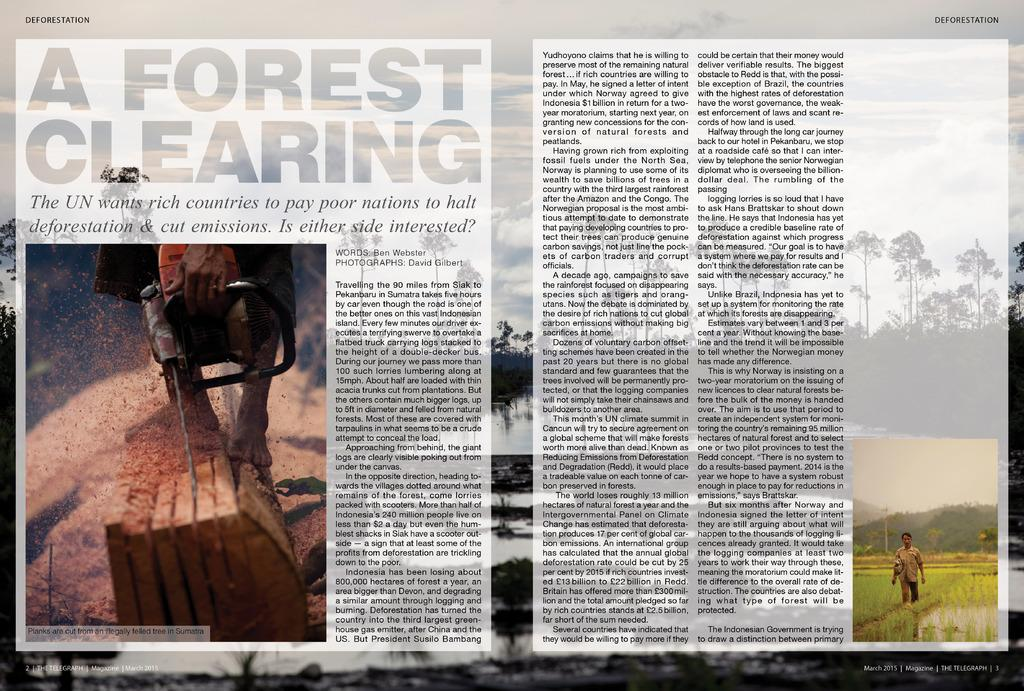What is featured on the poster in the image? There is a poster with text in the image. What activity is depicted in the image on the poster? The image on the poster shows a person walking in a paddy field. What type of vegetation can be seen in the image? There are trees visible in the image. What is the condition of the sky in the image? The sky with clouds is present in the image. What is the person in the second image doing? There is an image of a person cutting wood with a machine. What natural element is visible in the image? Water is visible in the image. What type of oatmeal is being served with a fork in the image? There is no oatmeal or fork present in the image. What type of animal's tail can be seen in the image? There are no animals or tails present in the image. 